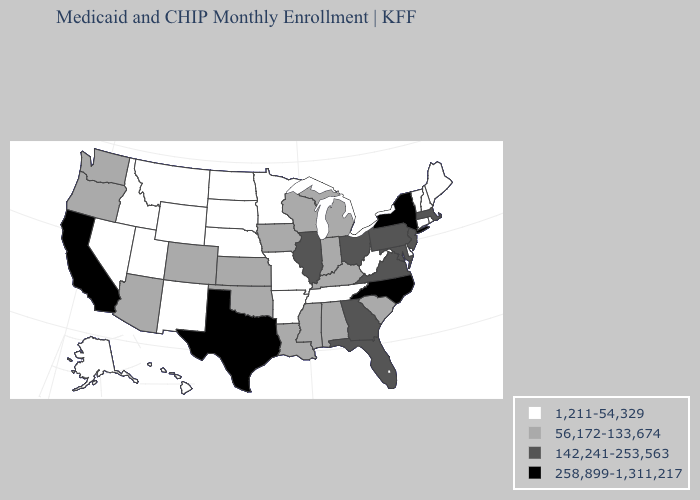What is the value of New York?
Quick response, please. 258,899-1,311,217. What is the highest value in the South ?
Answer briefly. 258,899-1,311,217. Name the states that have a value in the range 142,241-253,563?
Keep it brief. Florida, Georgia, Illinois, Maryland, Massachusetts, New Jersey, Ohio, Pennsylvania, Virginia. Which states hav the highest value in the South?
Be succinct. North Carolina, Texas. Does Arkansas have the lowest value in the South?
Answer briefly. Yes. What is the value of West Virginia?
Concise answer only. 1,211-54,329. Does California have the same value as Texas?
Keep it brief. Yes. Name the states that have a value in the range 142,241-253,563?
Give a very brief answer. Florida, Georgia, Illinois, Maryland, Massachusetts, New Jersey, Ohio, Pennsylvania, Virginia. What is the value of New Jersey?
Be succinct. 142,241-253,563. What is the highest value in states that border Oregon?
Quick response, please. 258,899-1,311,217. What is the value of Indiana?
Write a very short answer. 56,172-133,674. What is the lowest value in the West?
Quick response, please. 1,211-54,329. Is the legend a continuous bar?
Answer briefly. No. What is the value of New Hampshire?
Give a very brief answer. 1,211-54,329. Which states hav the highest value in the South?
Short answer required. North Carolina, Texas. 